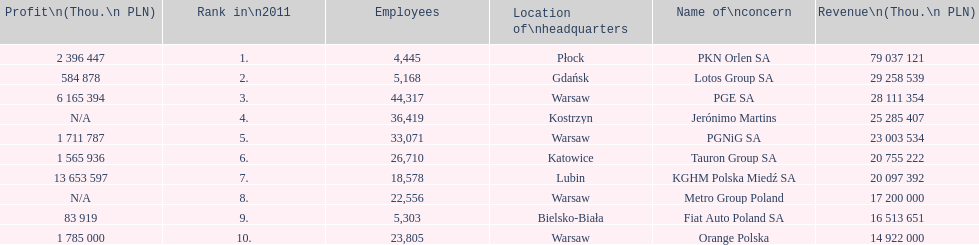What is the difference in employees for rank 1 and rank 3? 39,872 employees. 